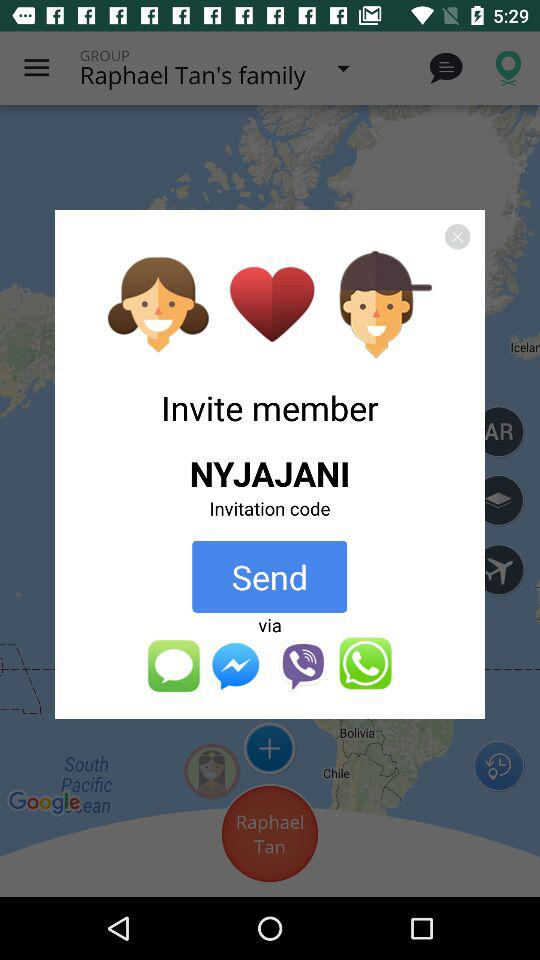What is the name of the "Invite member"? The name is "NYJAJANI". 